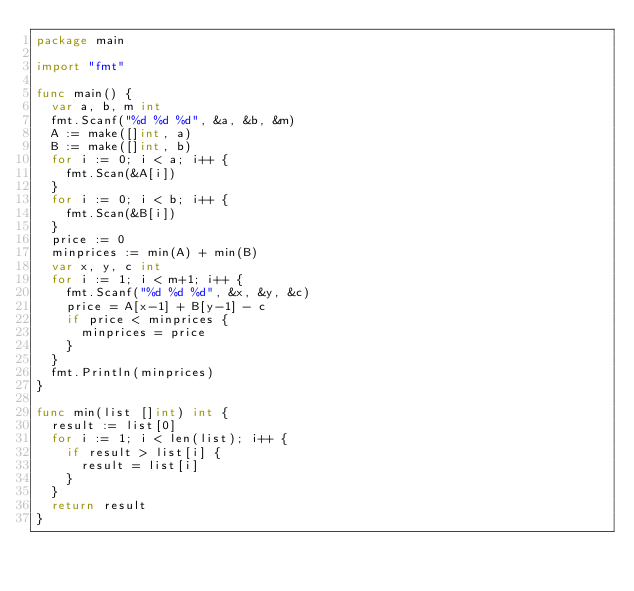<code> <loc_0><loc_0><loc_500><loc_500><_Go_>package main

import "fmt"

func main() {
	var a, b, m int
	fmt.Scanf("%d %d %d", &a, &b, &m)
	A := make([]int, a)
	B := make([]int, b)
	for i := 0; i < a; i++ {
		fmt.Scan(&A[i])
	}
	for i := 0; i < b; i++ {
		fmt.Scan(&B[i])
	}
	price := 0
	minprices := min(A) + min(B)
	var x, y, c int
	for i := 1; i < m+1; i++ {
		fmt.Scanf("%d %d %d", &x, &y, &c)
		price = A[x-1] + B[y-1] - c
		if price < minprices {
			minprices = price
		}
	}
	fmt.Println(minprices)
}

func min(list []int) int {
	result := list[0]
	for i := 1; i < len(list); i++ {
		if result > list[i] {
			result = list[i]
		}
	}
	return result
}
</code> 